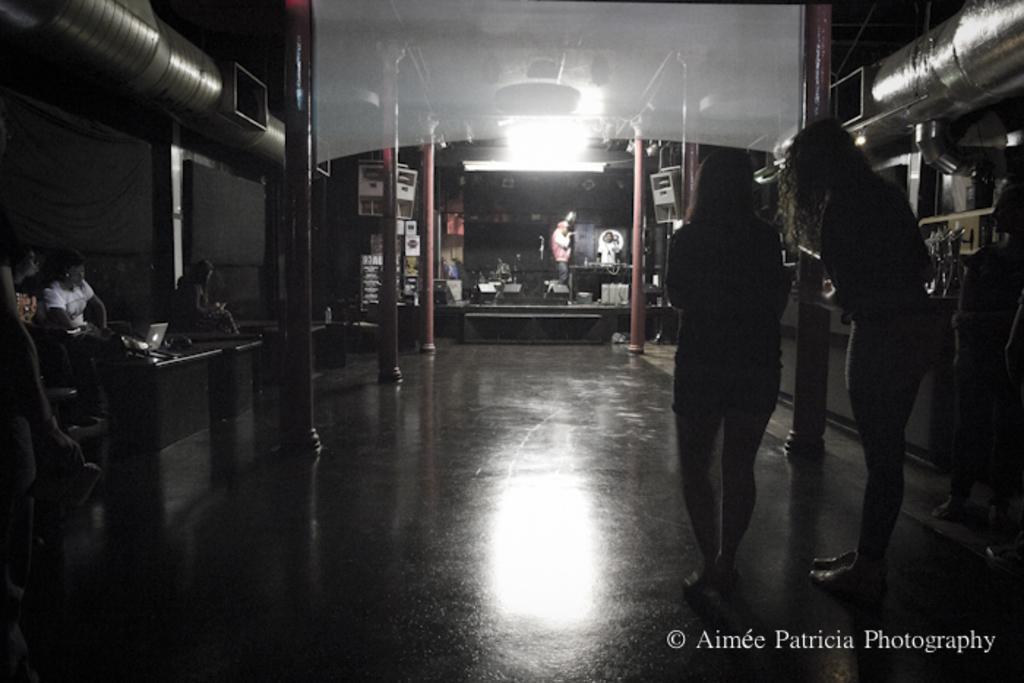In one or two sentences, can you explain what this image depicts? On the left side of the image we can see people sitting and there are tables. On the right there are two ladies standing. In the background there are pillars and we can see people standing. There is some equipment. 